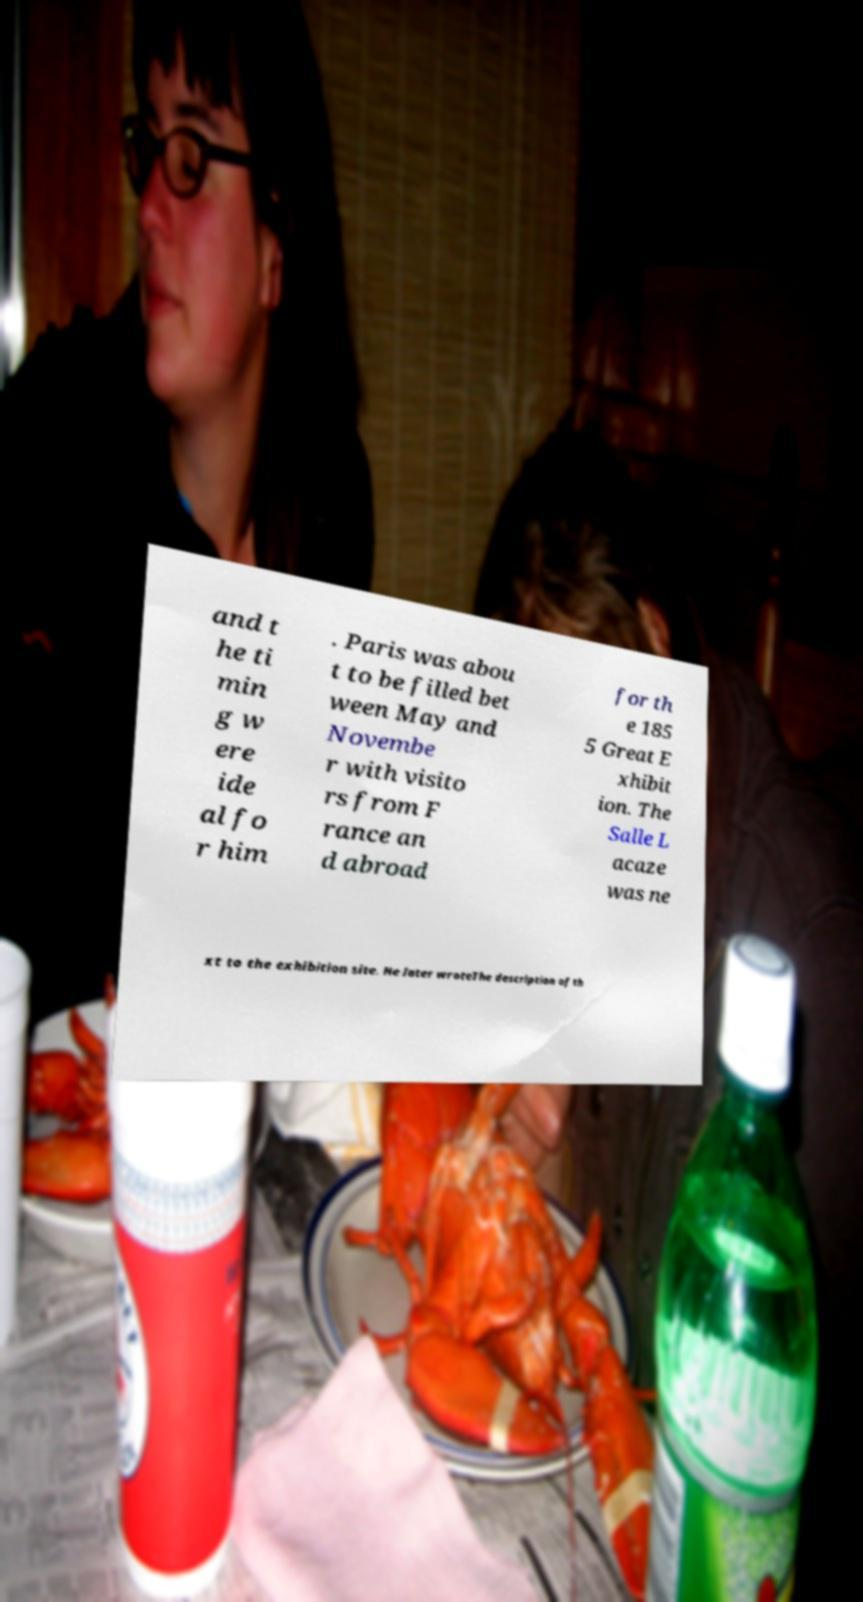Could you assist in decoding the text presented in this image and type it out clearly? and t he ti min g w ere ide al fo r him . Paris was abou t to be filled bet ween May and Novembe r with visito rs from F rance an d abroad for th e 185 5 Great E xhibit ion. The Salle L acaze was ne xt to the exhibition site. He later wroteThe description of th 